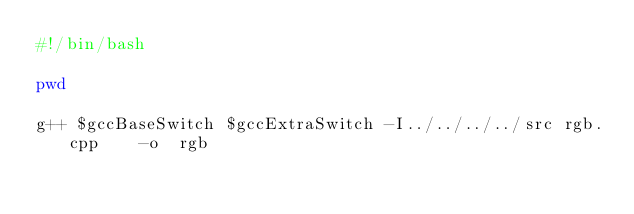<code> <loc_0><loc_0><loc_500><loc_500><_Bash_>#!/bin/bash

pwd

g++ $gccBaseSwitch $gccExtraSwitch -I../../../../src rgb.cpp    -o  rgb
 

</code> 